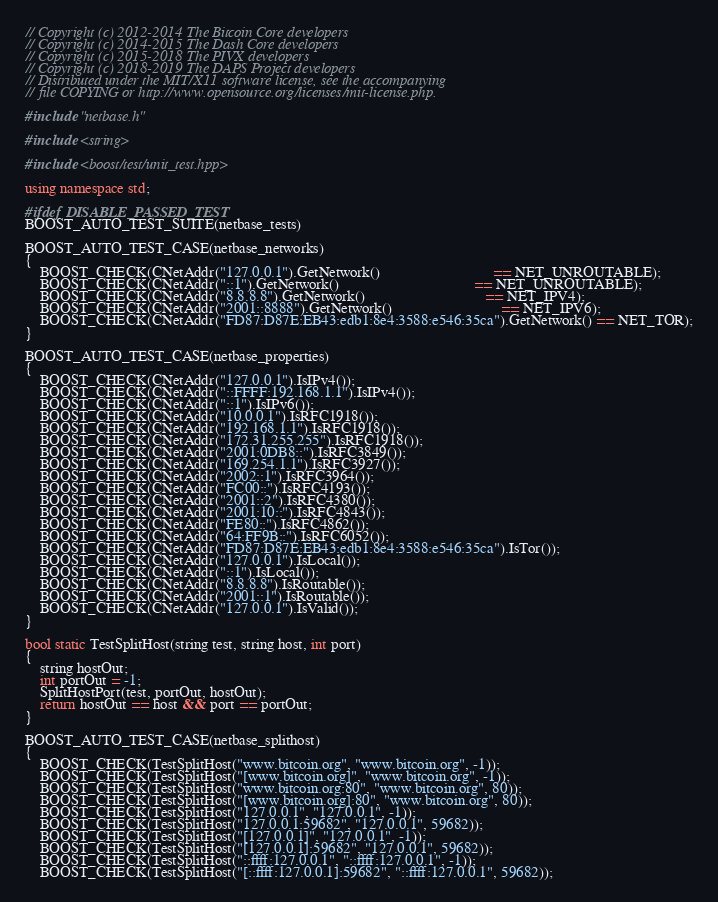Convert code to text. <code><loc_0><loc_0><loc_500><loc_500><_C++_>// Copyright (c) 2012-2014 The Bitcoin Core developers
// Copyright (c) 2014-2015 The Dash Core developers
// Copyright (c) 2015-2018 The PIVX developers
// Copyright (c) 2018-2019 The DAPS Project developers
// Distributed under the MIT/X11 software license, see the accompanying
// file COPYING or http://www.opensource.org/licenses/mit-license.php.

#include "netbase.h"

#include <string>

#include <boost/test/unit_test.hpp>

using namespace std;

#ifdef DISABLE_PASSED_TEST
BOOST_AUTO_TEST_SUITE(netbase_tests)

BOOST_AUTO_TEST_CASE(netbase_networks)
{
    BOOST_CHECK(CNetAddr("127.0.0.1").GetNetwork()                              == NET_UNROUTABLE);
    BOOST_CHECK(CNetAddr("::1").GetNetwork()                                    == NET_UNROUTABLE);
    BOOST_CHECK(CNetAddr("8.8.8.8").GetNetwork()                                == NET_IPV4);
    BOOST_CHECK(CNetAddr("2001::8888").GetNetwork()                             == NET_IPV6);
    BOOST_CHECK(CNetAddr("FD87:D87E:EB43:edb1:8e4:3588:e546:35ca").GetNetwork() == NET_TOR);
}

BOOST_AUTO_TEST_CASE(netbase_properties)
{
    BOOST_CHECK(CNetAddr("127.0.0.1").IsIPv4());
    BOOST_CHECK(CNetAddr("::FFFF:192.168.1.1").IsIPv4());
    BOOST_CHECK(CNetAddr("::1").IsIPv6());
    BOOST_CHECK(CNetAddr("10.0.0.1").IsRFC1918());
    BOOST_CHECK(CNetAddr("192.168.1.1").IsRFC1918());
    BOOST_CHECK(CNetAddr("172.31.255.255").IsRFC1918());
    BOOST_CHECK(CNetAddr("2001:0DB8::").IsRFC3849());
    BOOST_CHECK(CNetAddr("169.254.1.1").IsRFC3927());
    BOOST_CHECK(CNetAddr("2002::1").IsRFC3964());
    BOOST_CHECK(CNetAddr("FC00::").IsRFC4193());
    BOOST_CHECK(CNetAddr("2001::2").IsRFC4380());
    BOOST_CHECK(CNetAddr("2001:10::").IsRFC4843());
    BOOST_CHECK(CNetAddr("FE80::").IsRFC4862());
    BOOST_CHECK(CNetAddr("64:FF9B::").IsRFC6052());
    BOOST_CHECK(CNetAddr("FD87:D87E:EB43:edb1:8e4:3588:e546:35ca").IsTor());
    BOOST_CHECK(CNetAddr("127.0.0.1").IsLocal());
    BOOST_CHECK(CNetAddr("::1").IsLocal());
    BOOST_CHECK(CNetAddr("8.8.8.8").IsRoutable());
    BOOST_CHECK(CNetAddr("2001::1").IsRoutable());
    BOOST_CHECK(CNetAddr("127.0.0.1").IsValid());
}

bool static TestSplitHost(string test, string host, int port)
{
    string hostOut;
    int portOut = -1;
    SplitHostPort(test, portOut, hostOut);
    return hostOut == host && port == portOut;
}

BOOST_AUTO_TEST_CASE(netbase_splithost)
{
    BOOST_CHECK(TestSplitHost("www.bitcoin.org", "www.bitcoin.org", -1));
    BOOST_CHECK(TestSplitHost("[www.bitcoin.org]", "www.bitcoin.org", -1));
    BOOST_CHECK(TestSplitHost("www.bitcoin.org:80", "www.bitcoin.org", 80));
    BOOST_CHECK(TestSplitHost("[www.bitcoin.org]:80", "www.bitcoin.org", 80));
    BOOST_CHECK(TestSplitHost("127.0.0.1", "127.0.0.1", -1));
    BOOST_CHECK(TestSplitHost("127.0.0.1:59682", "127.0.0.1", 59682));
    BOOST_CHECK(TestSplitHost("[127.0.0.1]", "127.0.0.1", -1));
    BOOST_CHECK(TestSplitHost("[127.0.0.1]:59682", "127.0.0.1", 59682));
    BOOST_CHECK(TestSplitHost("::ffff:127.0.0.1", "::ffff:127.0.0.1", -1));
    BOOST_CHECK(TestSplitHost("[::ffff:127.0.0.1]:59682", "::ffff:127.0.0.1", 59682));</code> 